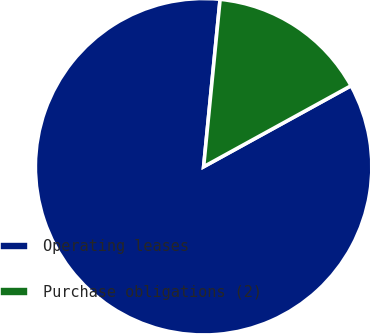Convert chart to OTSL. <chart><loc_0><loc_0><loc_500><loc_500><pie_chart><fcel>Operating leases<fcel>Purchase obligations (2)<nl><fcel>84.56%<fcel>15.44%<nl></chart> 